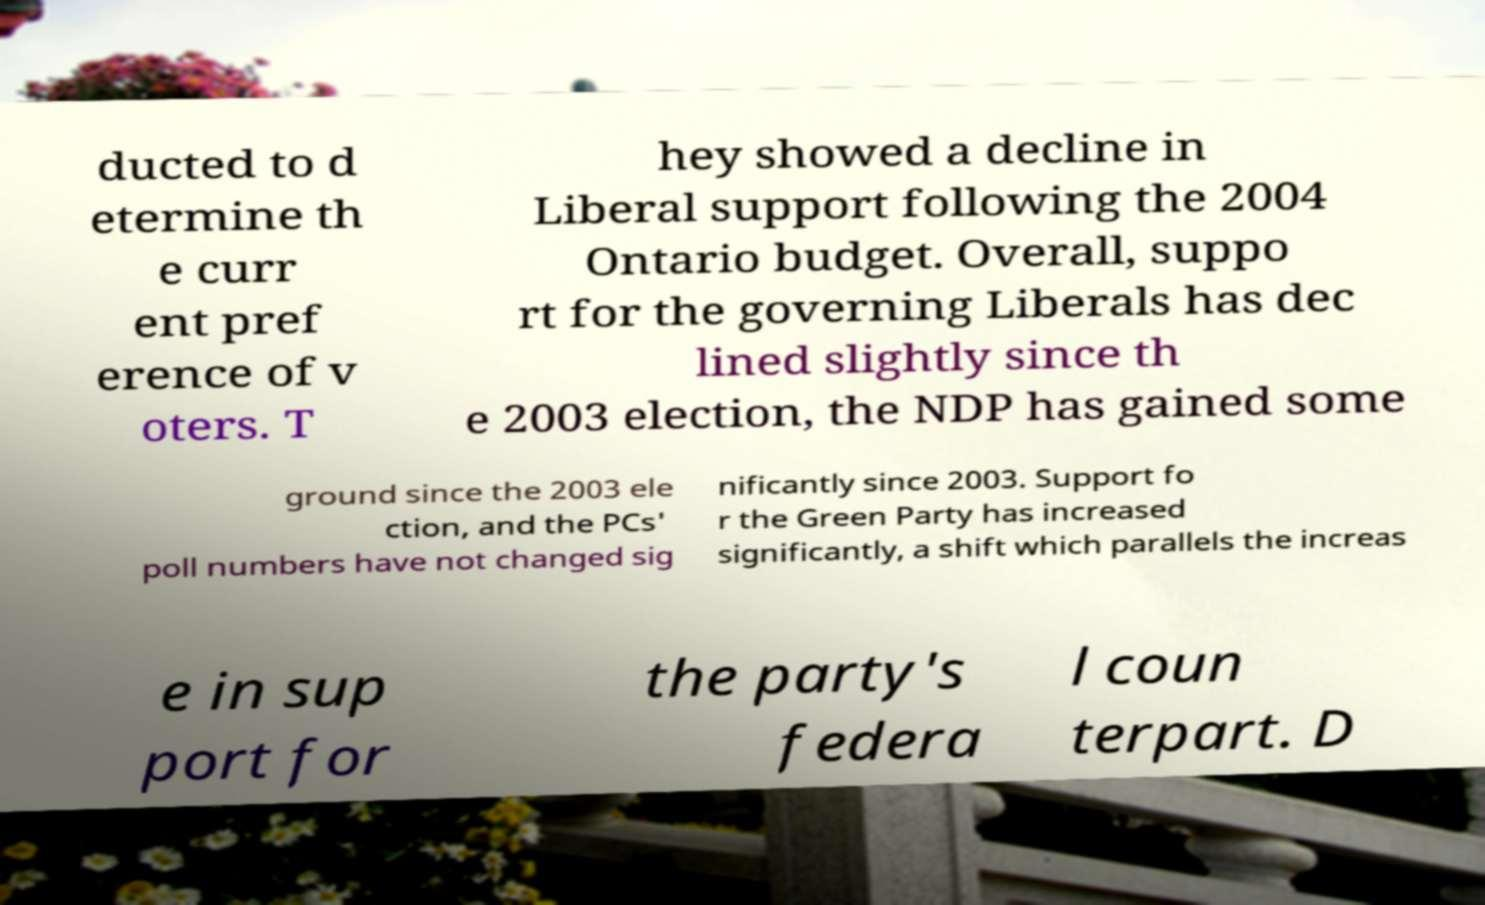I need the written content from this picture converted into text. Can you do that? ducted to d etermine th e curr ent pref erence of v oters. T hey showed a decline in Liberal support following the 2004 Ontario budget. Overall, suppo rt for the governing Liberals has dec lined slightly since th e 2003 election, the NDP has gained some ground since the 2003 ele ction, and the PCs' poll numbers have not changed sig nificantly since 2003. Support fo r the Green Party has increased significantly, a shift which parallels the increas e in sup port for the party's federa l coun terpart. D 